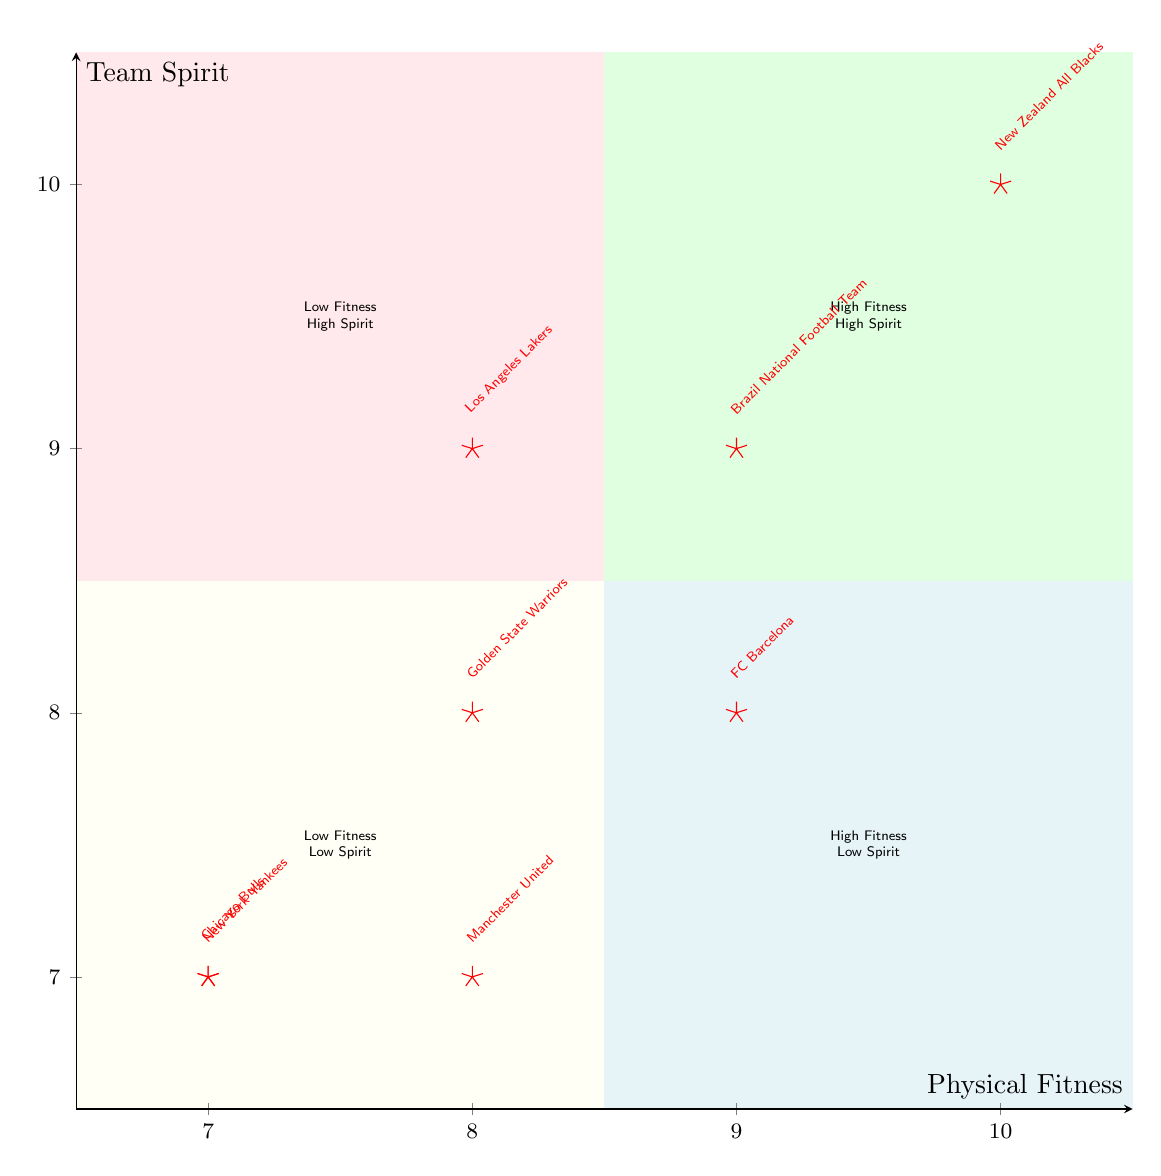What is the team with the highest physical fitness score? The highest physical fitness score in the diagram is 10, achieved by the New Zealand All Blacks.
Answer: New Zealand All Blacks Which team has the highest team spirit? Los Angeles Lakers and New Zealand All Blacks both have the highest team spirit score of 10.
Answer: Los Angeles Lakers and New Zealand All Blacks How many teams are located in the "High Fitness High Spirit" quadrant? There are three teams in the "High Fitness High Spirit" quadrant, specifically the New Zealand All Blacks, FC Barcelona, and Brazil National Football Team.
Answer: 3 Which team has a lower team spirit than physical fitness? The Chicago Bulls have equal scores in both categories, but the Manchester United team has lower team spirit (7) than its physical fitness score (8).
Answer: Manchester United What physical fitness score corresponds to the Chicago Bulls? The Chicago Bulls have a physical fitness score of 7.
Answer: 7 Does any team have low fitness and high spirit? Yes, the Los Angeles Lakers have high team spirit (9) and lower fitness (8).
Answer: Yes How many teams fall into the "Low Fitness Low Spirit" quadrant? The "Low Fitness Low Spirit" quadrant includes two teams: Chicago Bulls and New York Yankees.
Answer: 2 Which teams have the same scores for both physical fitness and team spirit? Both the Chicago Bulls and New York Yankees have a score of 7 in both categories.
Answer: Chicago Bulls and New York Yankees What is the team spirit of the New Zealand All Blacks? The New Zealand All Blacks have a team spirit score of 10.
Answer: 10 